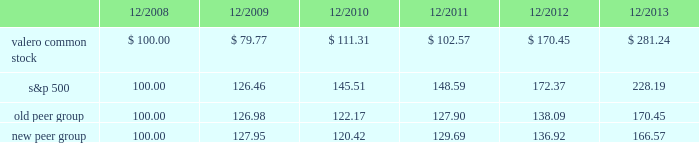Table of contents the following performance graph is not 201csoliciting material , 201d is not deemed filed with the sec , and is not to be incorporated by reference into any of valero 2019s filings under the securities act of 1933 or the securities exchange act of 1934 , as amended , respectively .
This performance graph and the related textual information are based on historical data and are not indicative of future performance .
The following line graph compares the cumulative total return 1 on an investment in our common stock against the cumulative total return of the s&p 500 composite index and an index of peer companies ( that we selected ) for the five-year period commencing december 31 , 2008 and ending december 31 , 2013 .
Our peer group comprises the following 11 companies : alon usa energy , inc. ; bp plc ; cvr energy , inc. ; delek us holdings , inc .
( dk ) ; hollyfrontier corporation ; marathon petroleum corporation ; pbf energy inc .
( pbf ) ; phillips 66 ; royal dutch shell plc ; tesoro corporation ; and western refining , inc .
Our peer group previously included hess corporation , but it has exited the refining business , and was replaced in our peer group by dk and pbf who are also engaged in refining operations .
Comparison of 5 year cumulative total return1 among valero energy corporation , the s&p 500 index , old peer group , and new peer group .
____________ 1 assumes that an investment in valero common stock and each index was $ 100 on december 31 , 2008 .
201ccumulative total return 201d is based on share price appreciation plus reinvestment of dividends from december 31 , 2008 through december 31 , 2013. .
What is the total return in valero common stock from 2008-2013? 
Computations: (281.24 - 100)
Answer: 181.24. 